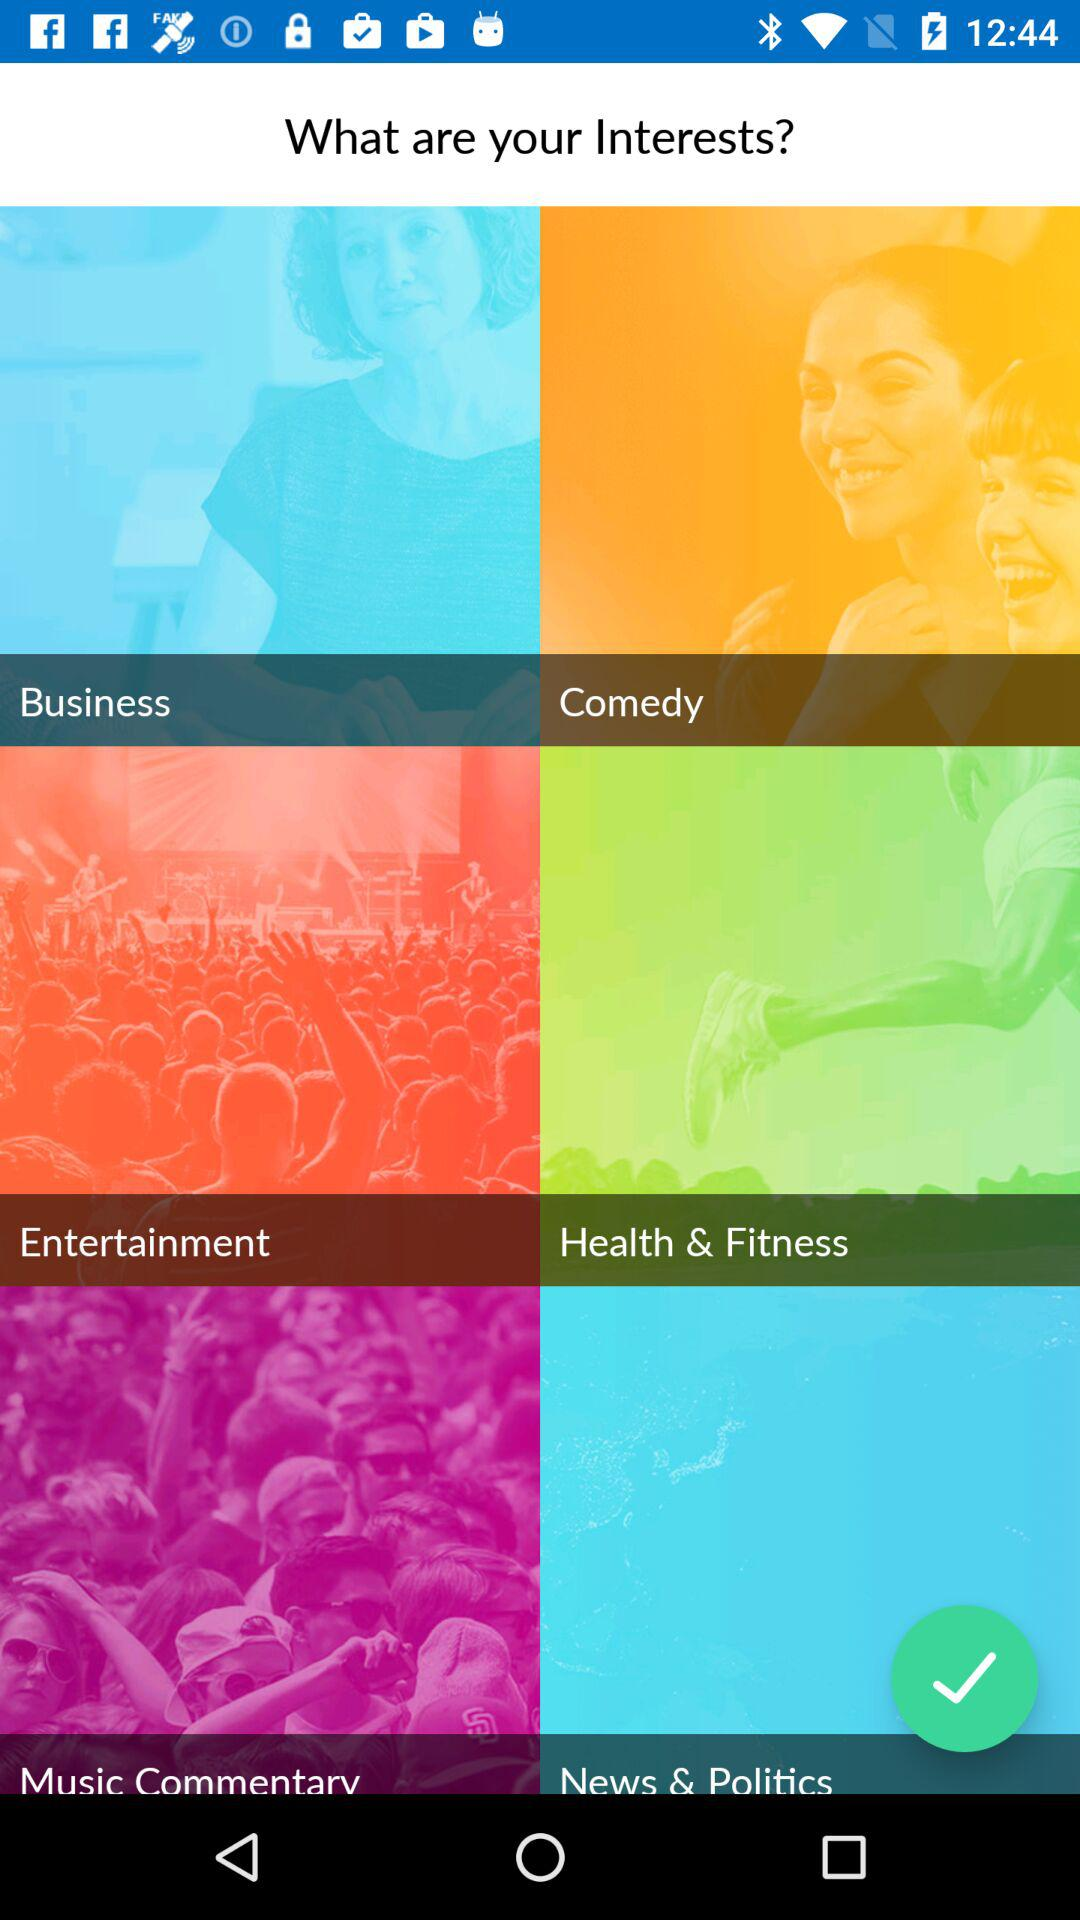How many interests are there in total?
Answer the question using a single word or phrase. 6 